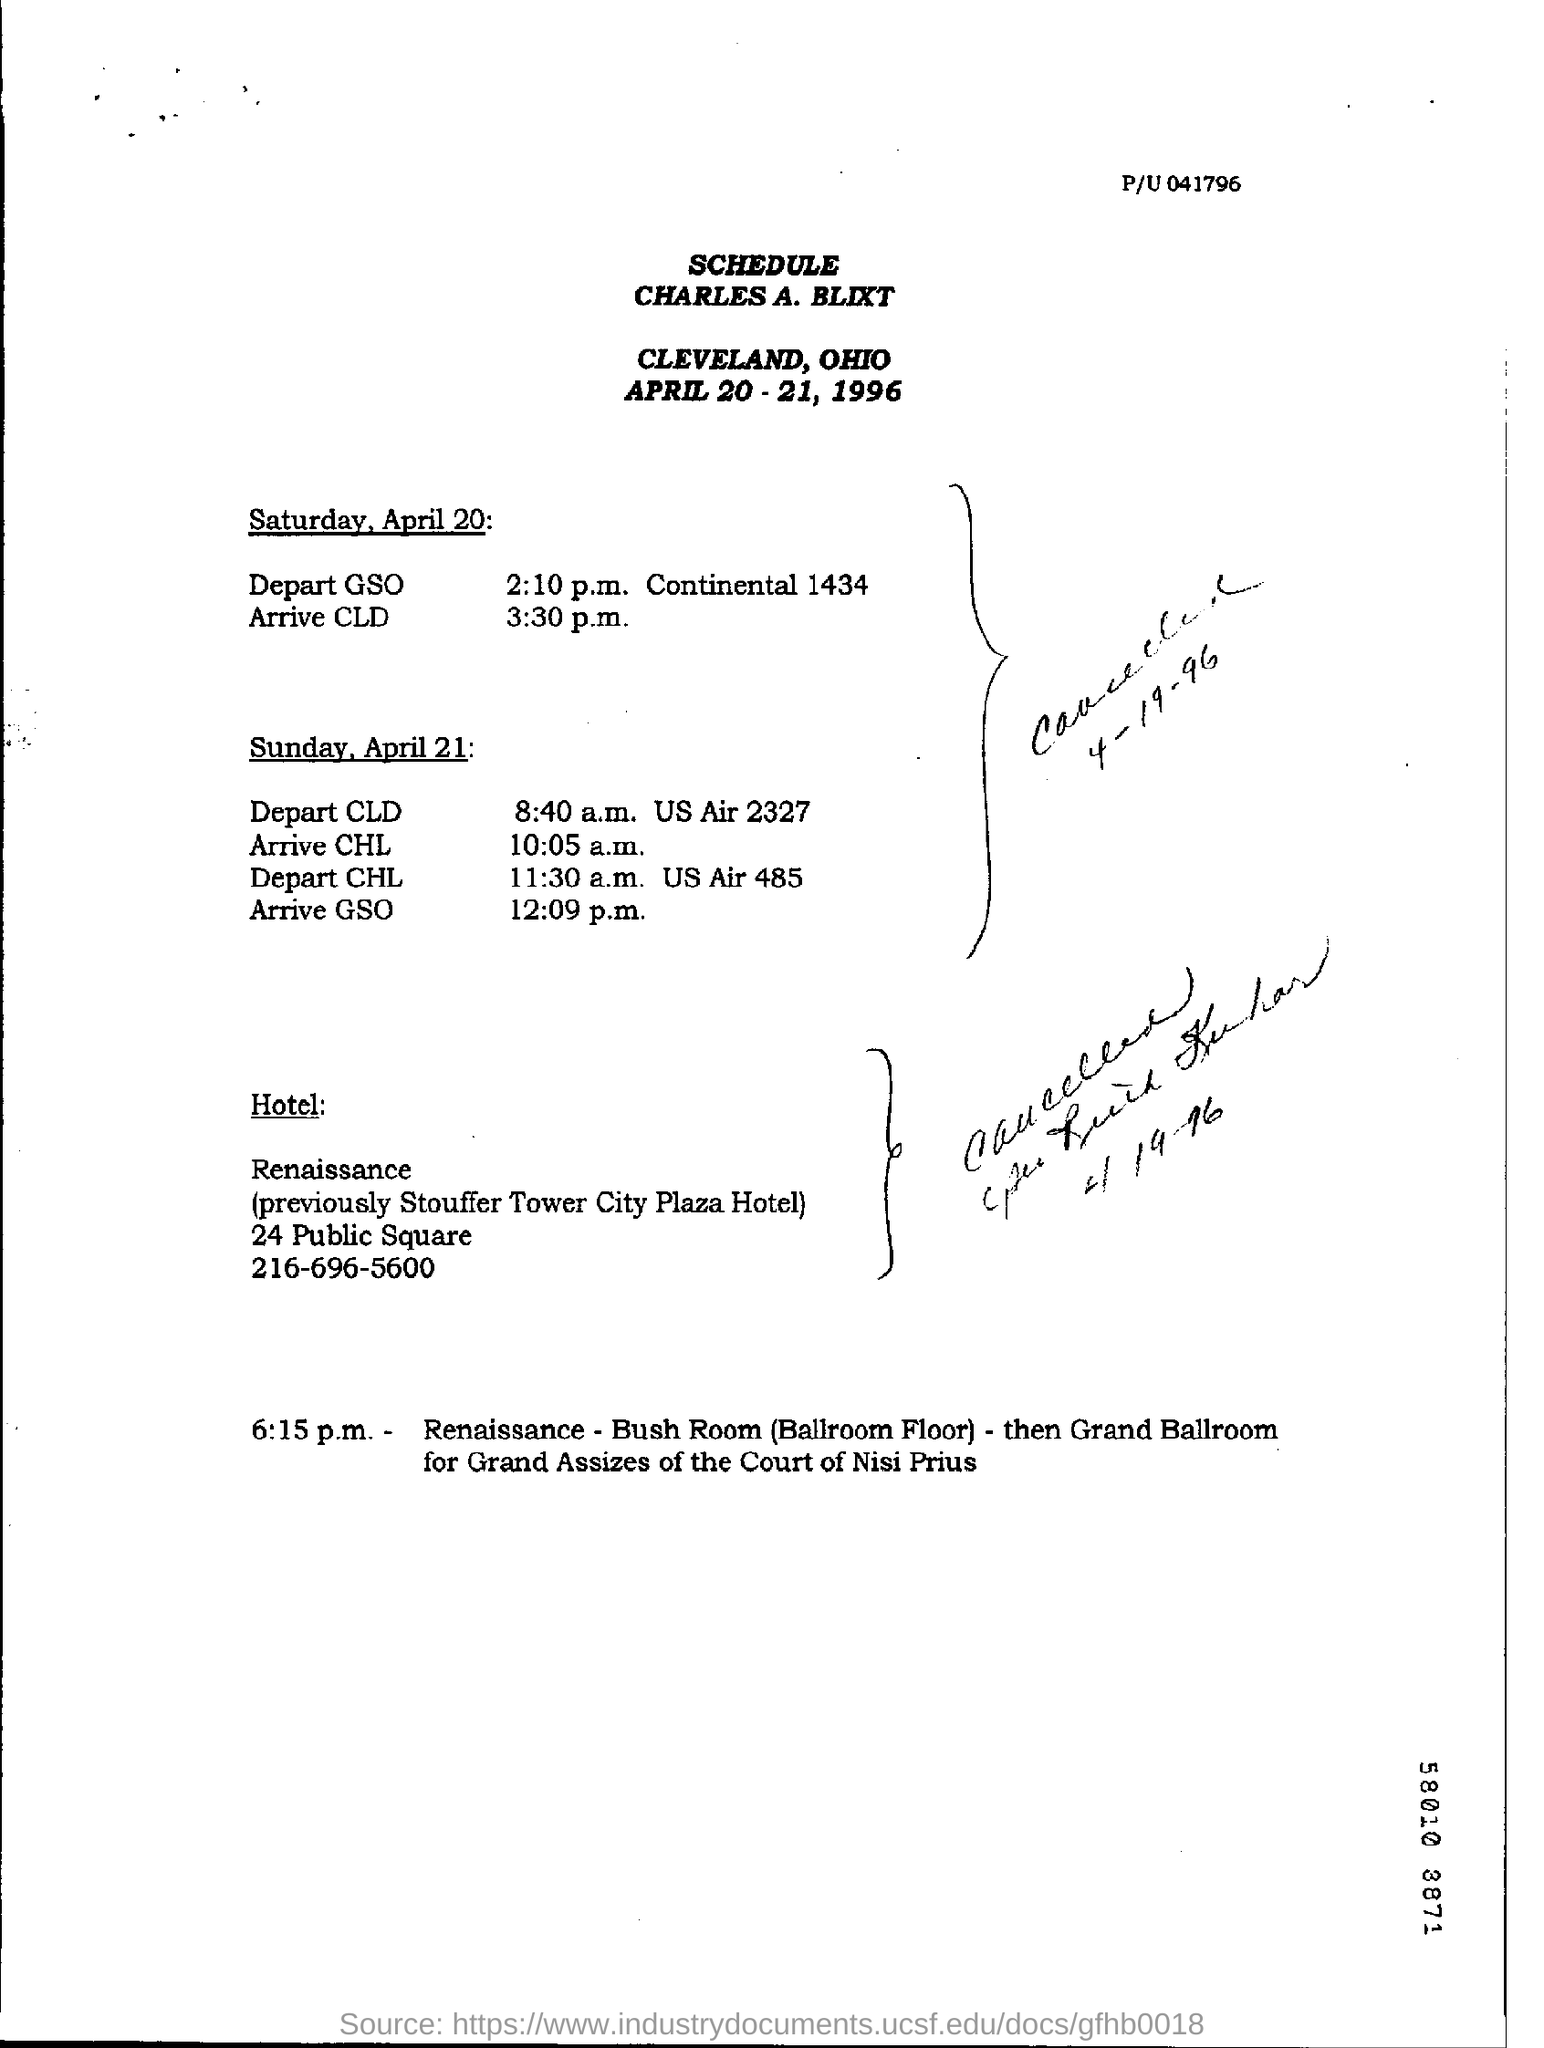What does renaissance previously called ?
Offer a terse response. Stouffer Tower City Plaza Hotel. What day of the week is april 20?
Your response must be concise. Saturday. What day of the week is april 21?
Offer a terse response. Sunday. 